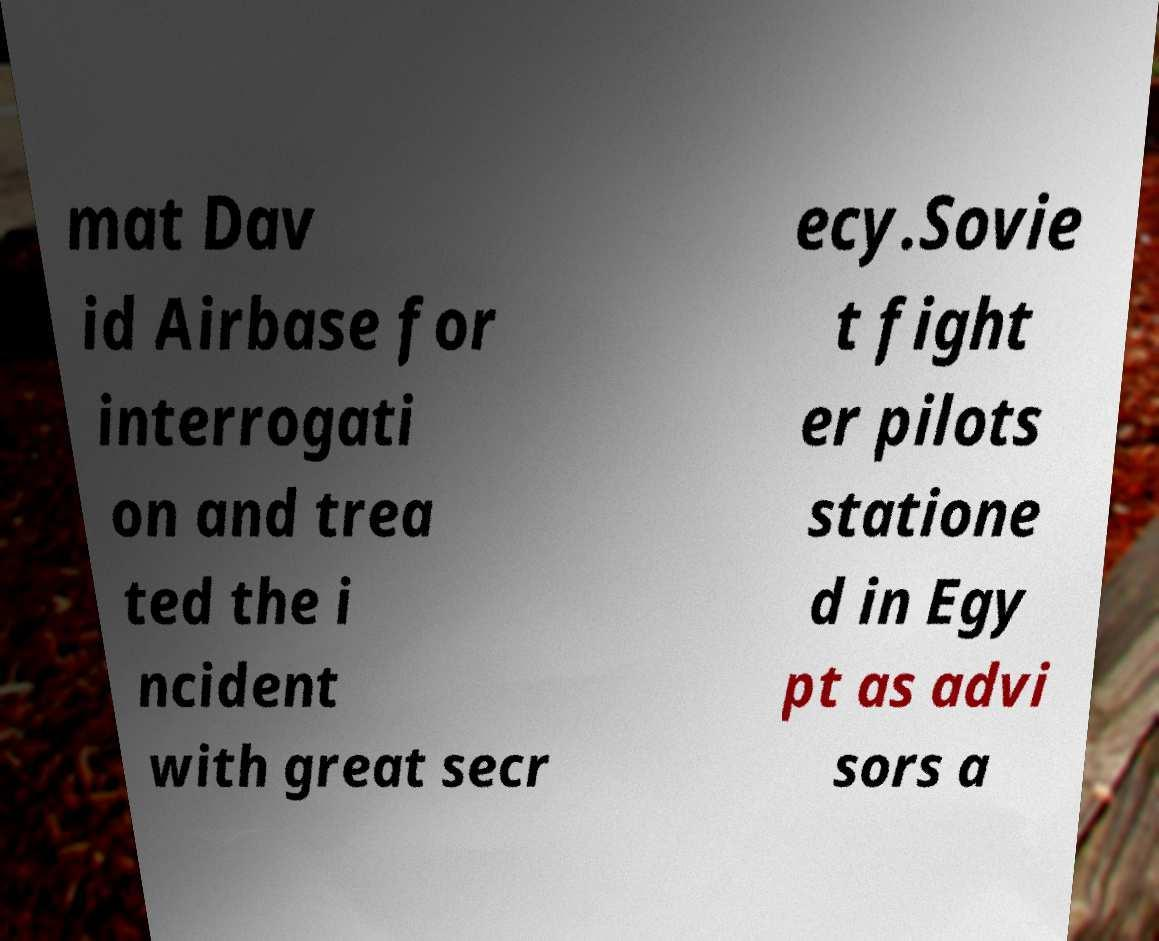Can you read and provide the text displayed in the image?This photo seems to have some interesting text. Can you extract and type it out for me? mat Dav id Airbase for interrogati on and trea ted the i ncident with great secr ecy.Sovie t fight er pilots statione d in Egy pt as advi sors a 